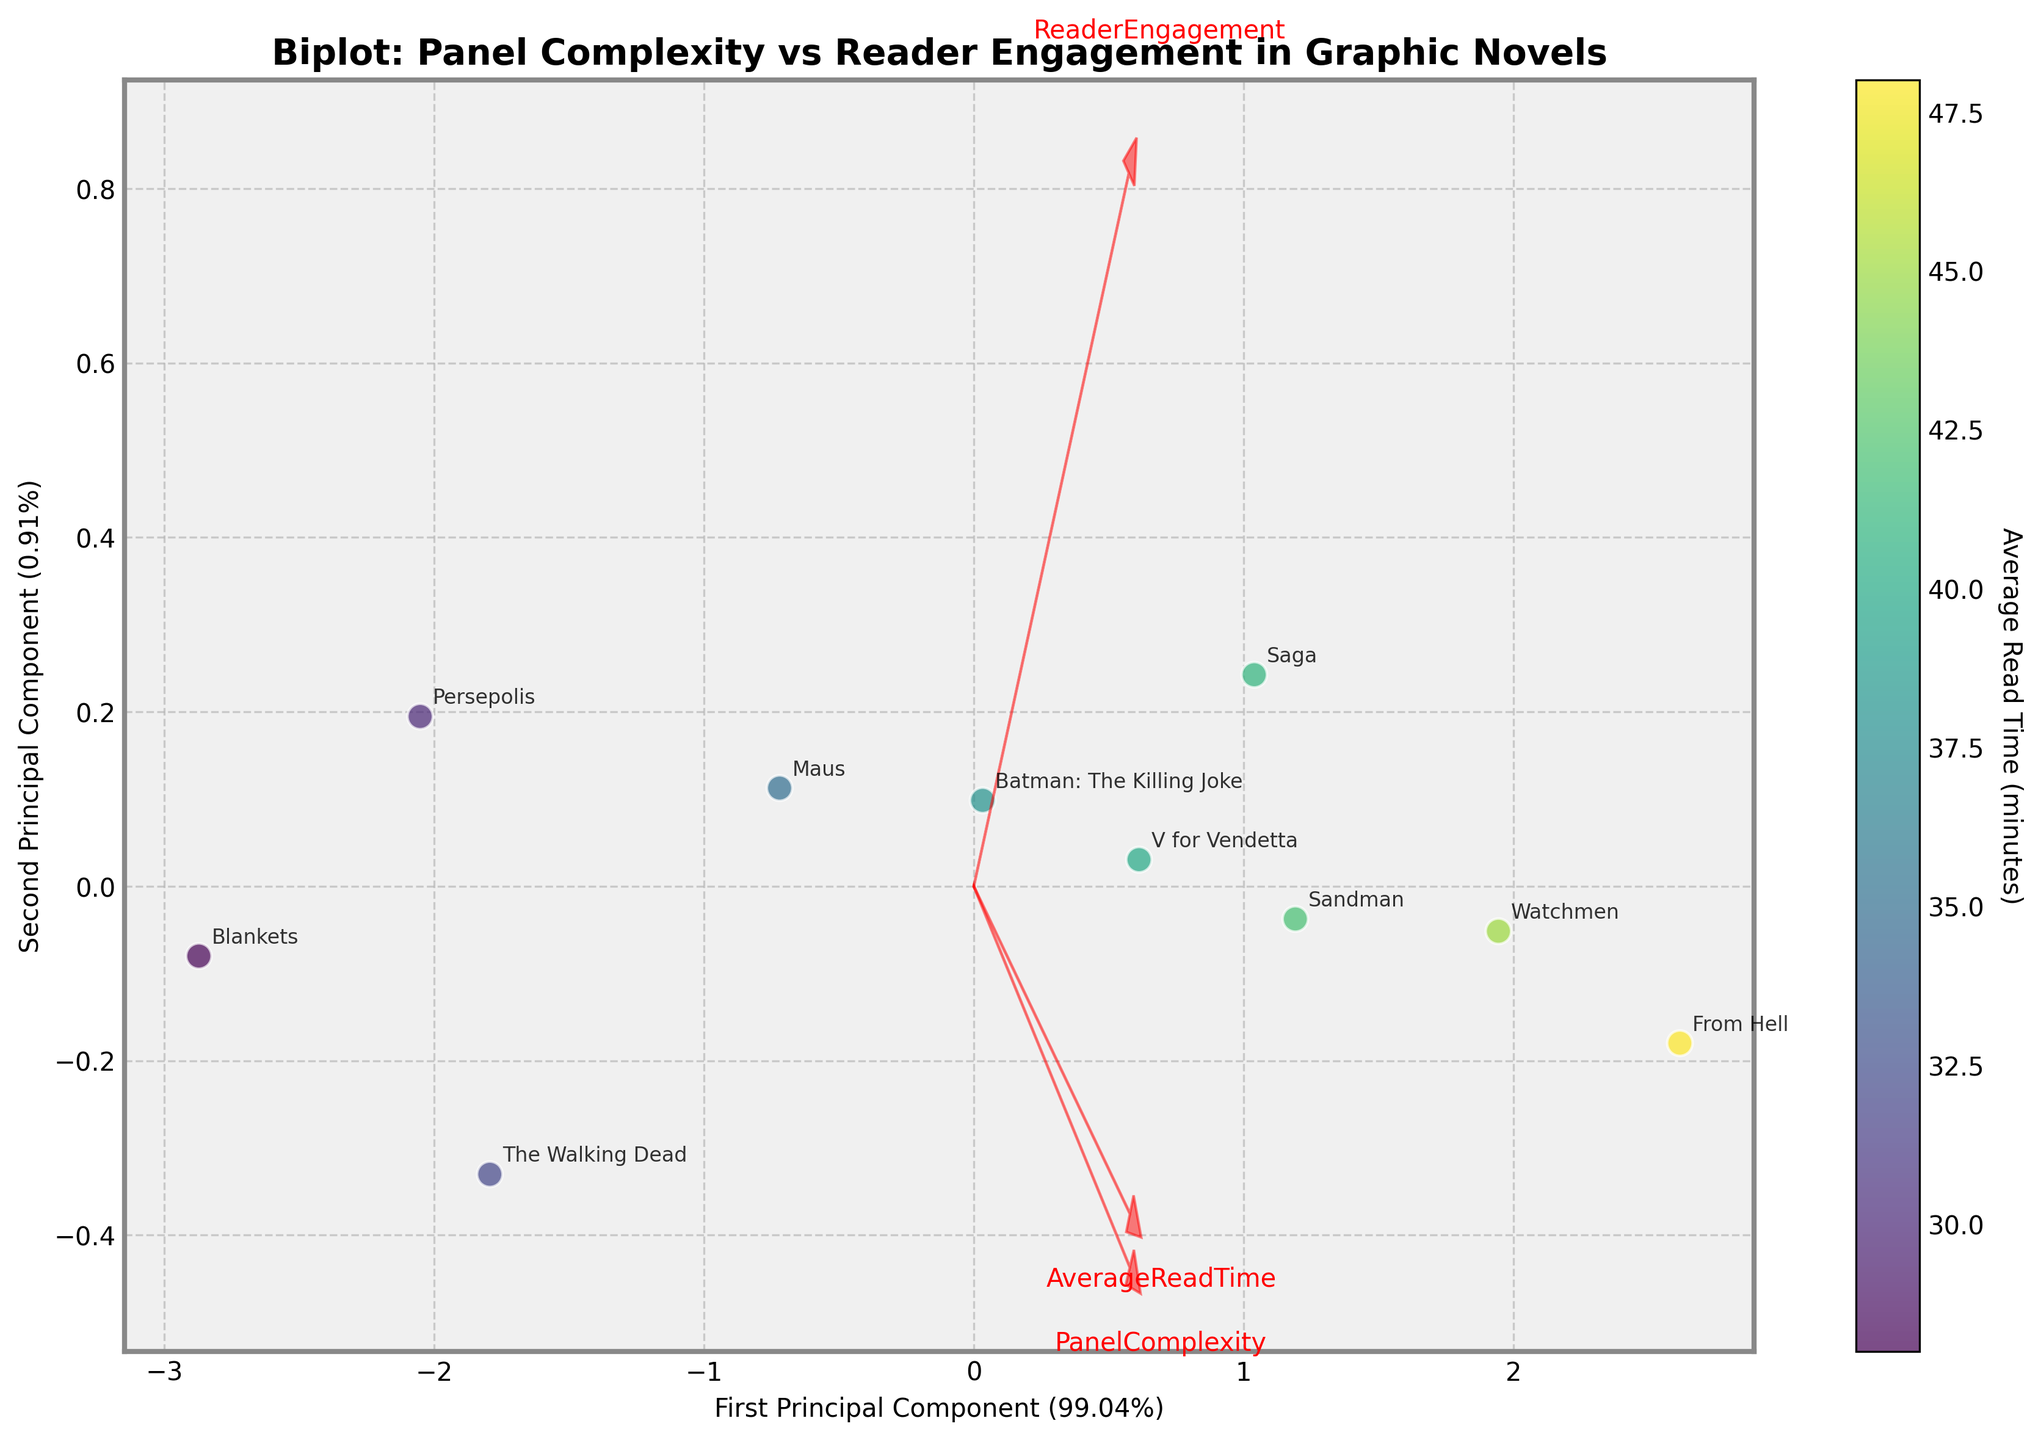What is the title of the biplot? The title of the plot is typically displayed at the top center of the figure. Here, it states "Biplot: Panel Complexity vs Reader Engagement in Graphic Novels".
Answer: Biplot: Panel Complexity vs Reader Engagement in Graphic Novels Which novel has the highest PanelComplexity? By locating the data point that is positioned furthest in the direction of the PanelComplexity vector, it corresponds to "From Hell".
Answer: From Hell What is the color corresponding to the data point for "Maus"? The color in the scatter plot represents the Average Read Time, highlighted by the color bar scale. "Maus" lies within the 35 range, which is depicted by a color around the middle of the viridis scale, possibly a greenish hue.
Answer: Greenish How much of the variance is explained by the first principal component? The x-axis label mentions the percentage of variance explained, which is around 48.12%.
Answer: 48.12% Which novels have a higher reading engagement value: "Sandman" or "Persepolis"? Comparing their positions to the ReaderEngagement vector, "Sandman" is placed further along this vector than "Persepolis", indicating a higher value.
Answer: Sandman What are the three features represented by the vectors? Each vector has labels, indicating "PanelComplexity", "ReaderEngagement", and "AverageReadTime". These are the features included in the PCA.
Answer: PanelComplexity, ReaderEngagement, AverageReadTime What does the color bar represent? The color bar is labeled "Average Read Time (minutes)", signifying that the color of each data point indicates the average time readers spent on the graphic novel.
Answer: Average Read Time (minutes) Which graphic novels have an Average Read Time above 45 minutes? Data points colored towards the higher end of the color bar represent longer read times. "Watchmen", "Sandman", "From Hell", and possibly "Saga" fall within this color range.
Answer: Watchmen, From Hell (possibly Saga and Sandman) How closely do 'PanelComplexity' and 'ReaderEngagement' vectors align? Observing the angles, these two vectors are fairly close, indicating high positive correlation.
Answer: High positive correlation Is the average read time more strongly correlated with PanelComplexity or ReaderEngagement? Examining the direction and length of the corresponding vectors, 'AverageReadTime' aligns more with 'ReaderEngagement' and has a relatively comparable magnitude. This suggests it is similarly correlated with both but might slightly lean closer to 'ReaderEngagement'.
Answer: Slightly more correlated with ReaderEngagement 